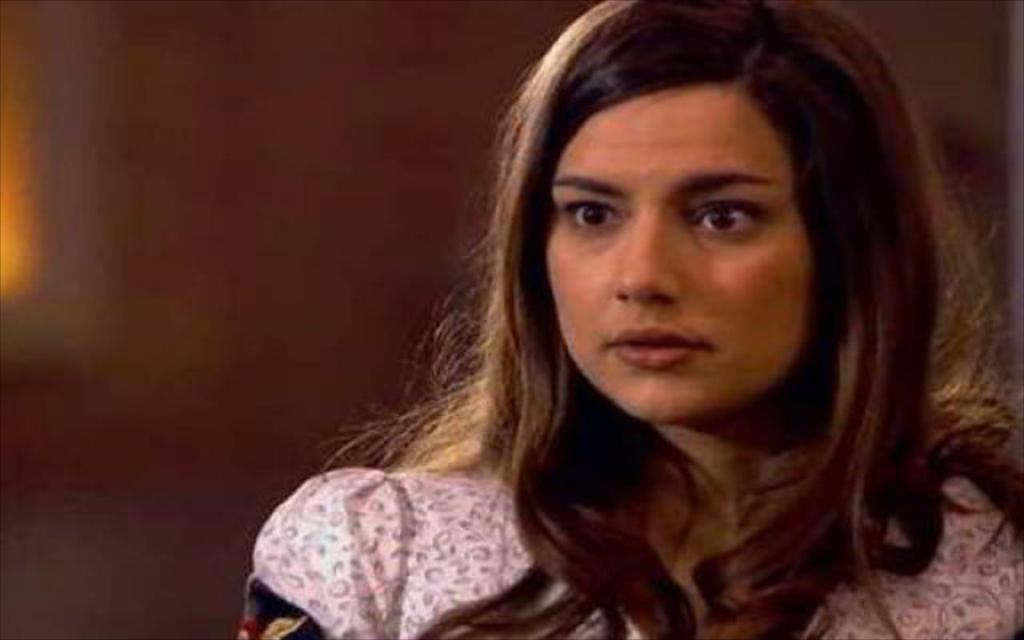Describe this image in one or two sentences. There is a woman. On the background we can see wall. 